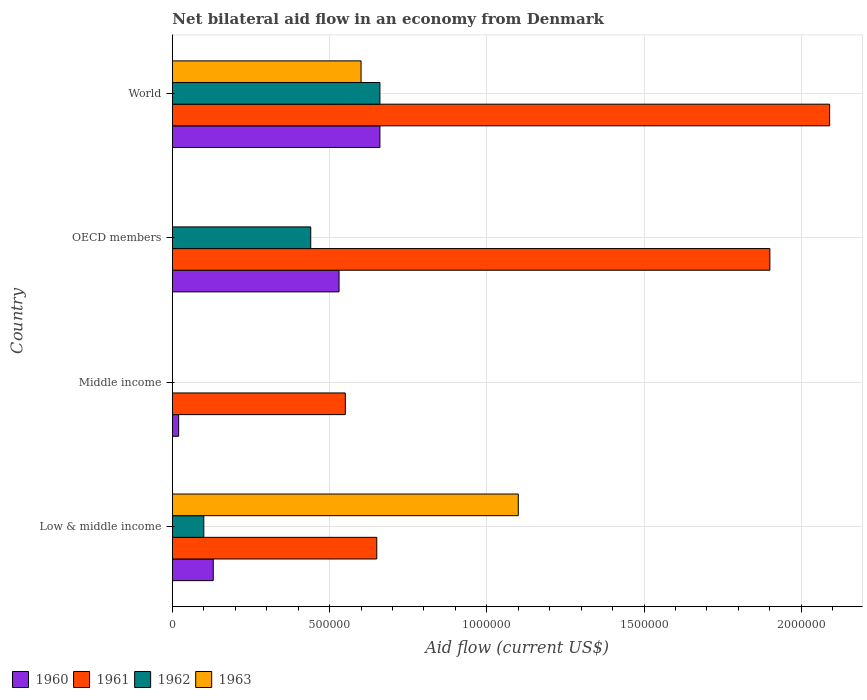How many different coloured bars are there?
Make the answer very short. 4. How many bars are there on the 4th tick from the top?
Your response must be concise. 4. How many bars are there on the 3rd tick from the bottom?
Provide a short and direct response. 3. In how many cases, is the number of bars for a given country not equal to the number of legend labels?
Provide a succinct answer. 2. Across all countries, what is the maximum net bilateral aid flow in 1961?
Your answer should be compact. 2.09e+06. Across all countries, what is the minimum net bilateral aid flow in 1960?
Make the answer very short. 2.00e+04. In which country was the net bilateral aid flow in 1962 maximum?
Keep it short and to the point. World. What is the total net bilateral aid flow in 1962 in the graph?
Your answer should be compact. 1.20e+06. What is the difference between the net bilateral aid flow in 1962 in Low & middle income and that in World?
Offer a very short reply. -5.60e+05. What is the average net bilateral aid flow in 1960 per country?
Provide a short and direct response. 3.35e+05. What is the difference between the net bilateral aid flow in 1963 and net bilateral aid flow in 1960 in Low & middle income?
Your response must be concise. 9.70e+05. What is the ratio of the net bilateral aid flow in 1960 in Middle income to that in World?
Provide a succinct answer. 0.03. Is the net bilateral aid flow in 1961 in Low & middle income less than that in OECD members?
Make the answer very short. Yes. What is the difference between the highest and the second highest net bilateral aid flow in 1962?
Keep it short and to the point. 2.20e+05. What is the difference between the highest and the lowest net bilateral aid flow in 1960?
Offer a terse response. 6.40e+05. In how many countries, is the net bilateral aid flow in 1960 greater than the average net bilateral aid flow in 1960 taken over all countries?
Your answer should be very brief. 2. Is it the case that in every country, the sum of the net bilateral aid flow in 1962 and net bilateral aid flow in 1961 is greater than the sum of net bilateral aid flow in 1963 and net bilateral aid flow in 1960?
Offer a terse response. No. How many bars are there?
Offer a very short reply. 13. Are all the bars in the graph horizontal?
Give a very brief answer. Yes. How many countries are there in the graph?
Your answer should be compact. 4. Does the graph contain any zero values?
Ensure brevity in your answer.  Yes. How many legend labels are there?
Offer a very short reply. 4. How are the legend labels stacked?
Your answer should be very brief. Horizontal. What is the title of the graph?
Offer a very short reply. Net bilateral aid flow in an economy from Denmark. What is the label or title of the X-axis?
Your answer should be compact. Aid flow (current US$). What is the label or title of the Y-axis?
Your response must be concise. Country. What is the Aid flow (current US$) in 1961 in Low & middle income?
Provide a succinct answer. 6.50e+05. What is the Aid flow (current US$) in 1962 in Low & middle income?
Offer a terse response. 1.00e+05. What is the Aid flow (current US$) of 1963 in Low & middle income?
Ensure brevity in your answer.  1.10e+06. What is the Aid flow (current US$) in 1960 in Middle income?
Offer a terse response. 2.00e+04. What is the Aid flow (current US$) in 1961 in Middle income?
Your response must be concise. 5.50e+05. What is the Aid flow (current US$) in 1962 in Middle income?
Ensure brevity in your answer.  0. What is the Aid flow (current US$) in 1963 in Middle income?
Keep it short and to the point. 0. What is the Aid flow (current US$) in 1960 in OECD members?
Ensure brevity in your answer.  5.30e+05. What is the Aid flow (current US$) in 1961 in OECD members?
Give a very brief answer. 1.90e+06. What is the Aid flow (current US$) in 1963 in OECD members?
Your answer should be compact. 0. What is the Aid flow (current US$) in 1960 in World?
Keep it short and to the point. 6.60e+05. What is the Aid flow (current US$) of 1961 in World?
Your answer should be very brief. 2.09e+06. What is the Aid flow (current US$) of 1962 in World?
Provide a succinct answer. 6.60e+05. Across all countries, what is the maximum Aid flow (current US$) of 1961?
Your response must be concise. 2.09e+06. Across all countries, what is the maximum Aid flow (current US$) of 1963?
Your answer should be very brief. 1.10e+06. Across all countries, what is the minimum Aid flow (current US$) in 1960?
Keep it short and to the point. 2.00e+04. Across all countries, what is the minimum Aid flow (current US$) in 1961?
Provide a short and direct response. 5.50e+05. Across all countries, what is the minimum Aid flow (current US$) of 1962?
Give a very brief answer. 0. Across all countries, what is the minimum Aid flow (current US$) in 1963?
Your answer should be compact. 0. What is the total Aid flow (current US$) of 1960 in the graph?
Make the answer very short. 1.34e+06. What is the total Aid flow (current US$) in 1961 in the graph?
Provide a succinct answer. 5.19e+06. What is the total Aid flow (current US$) of 1962 in the graph?
Keep it short and to the point. 1.20e+06. What is the total Aid flow (current US$) of 1963 in the graph?
Your answer should be very brief. 1.70e+06. What is the difference between the Aid flow (current US$) in 1961 in Low & middle income and that in Middle income?
Your answer should be compact. 1.00e+05. What is the difference between the Aid flow (current US$) of 1960 in Low & middle income and that in OECD members?
Offer a terse response. -4.00e+05. What is the difference between the Aid flow (current US$) of 1961 in Low & middle income and that in OECD members?
Ensure brevity in your answer.  -1.25e+06. What is the difference between the Aid flow (current US$) of 1962 in Low & middle income and that in OECD members?
Your answer should be very brief. -3.40e+05. What is the difference between the Aid flow (current US$) in 1960 in Low & middle income and that in World?
Keep it short and to the point. -5.30e+05. What is the difference between the Aid flow (current US$) of 1961 in Low & middle income and that in World?
Your answer should be compact. -1.44e+06. What is the difference between the Aid flow (current US$) in 1962 in Low & middle income and that in World?
Give a very brief answer. -5.60e+05. What is the difference between the Aid flow (current US$) of 1960 in Middle income and that in OECD members?
Your response must be concise. -5.10e+05. What is the difference between the Aid flow (current US$) of 1961 in Middle income and that in OECD members?
Keep it short and to the point. -1.35e+06. What is the difference between the Aid flow (current US$) in 1960 in Middle income and that in World?
Provide a short and direct response. -6.40e+05. What is the difference between the Aid flow (current US$) in 1961 in Middle income and that in World?
Ensure brevity in your answer.  -1.54e+06. What is the difference between the Aid flow (current US$) in 1961 in OECD members and that in World?
Provide a short and direct response. -1.90e+05. What is the difference between the Aid flow (current US$) of 1960 in Low & middle income and the Aid flow (current US$) of 1961 in Middle income?
Ensure brevity in your answer.  -4.20e+05. What is the difference between the Aid flow (current US$) of 1960 in Low & middle income and the Aid flow (current US$) of 1961 in OECD members?
Offer a terse response. -1.77e+06. What is the difference between the Aid flow (current US$) of 1960 in Low & middle income and the Aid flow (current US$) of 1962 in OECD members?
Your answer should be compact. -3.10e+05. What is the difference between the Aid flow (current US$) of 1960 in Low & middle income and the Aid flow (current US$) of 1961 in World?
Offer a very short reply. -1.96e+06. What is the difference between the Aid flow (current US$) in 1960 in Low & middle income and the Aid flow (current US$) in 1962 in World?
Offer a terse response. -5.30e+05. What is the difference between the Aid flow (current US$) of 1960 in Low & middle income and the Aid flow (current US$) of 1963 in World?
Your response must be concise. -4.70e+05. What is the difference between the Aid flow (current US$) in 1961 in Low & middle income and the Aid flow (current US$) in 1962 in World?
Your answer should be very brief. -10000. What is the difference between the Aid flow (current US$) in 1962 in Low & middle income and the Aid flow (current US$) in 1963 in World?
Keep it short and to the point. -5.00e+05. What is the difference between the Aid flow (current US$) in 1960 in Middle income and the Aid flow (current US$) in 1961 in OECD members?
Your answer should be compact. -1.88e+06. What is the difference between the Aid flow (current US$) in 1960 in Middle income and the Aid flow (current US$) in 1962 in OECD members?
Make the answer very short. -4.20e+05. What is the difference between the Aid flow (current US$) in 1960 in Middle income and the Aid flow (current US$) in 1961 in World?
Provide a short and direct response. -2.07e+06. What is the difference between the Aid flow (current US$) of 1960 in Middle income and the Aid flow (current US$) of 1962 in World?
Make the answer very short. -6.40e+05. What is the difference between the Aid flow (current US$) of 1960 in Middle income and the Aid flow (current US$) of 1963 in World?
Keep it short and to the point. -5.80e+05. What is the difference between the Aid flow (current US$) in 1961 in Middle income and the Aid flow (current US$) in 1963 in World?
Make the answer very short. -5.00e+04. What is the difference between the Aid flow (current US$) of 1960 in OECD members and the Aid flow (current US$) of 1961 in World?
Give a very brief answer. -1.56e+06. What is the difference between the Aid flow (current US$) in 1960 in OECD members and the Aid flow (current US$) in 1962 in World?
Offer a very short reply. -1.30e+05. What is the difference between the Aid flow (current US$) of 1960 in OECD members and the Aid flow (current US$) of 1963 in World?
Keep it short and to the point. -7.00e+04. What is the difference between the Aid flow (current US$) of 1961 in OECD members and the Aid flow (current US$) of 1962 in World?
Your answer should be very brief. 1.24e+06. What is the difference between the Aid flow (current US$) in 1961 in OECD members and the Aid flow (current US$) in 1963 in World?
Your answer should be very brief. 1.30e+06. What is the average Aid flow (current US$) of 1960 per country?
Make the answer very short. 3.35e+05. What is the average Aid flow (current US$) in 1961 per country?
Your answer should be compact. 1.30e+06. What is the average Aid flow (current US$) in 1963 per country?
Your answer should be compact. 4.25e+05. What is the difference between the Aid flow (current US$) of 1960 and Aid flow (current US$) of 1961 in Low & middle income?
Make the answer very short. -5.20e+05. What is the difference between the Aid flow (current US$) in 1960 and Aid flow (current US$) in 1962 in Low & middle income?
Provide a succinct answer. 3.00e+04. What is the difference between the Aid flow (current US$) in 1960 and Aid flow (current US$) in 1963 in Low & middle income?
Give a very brief answer. -9.70e+05. What is the difference between the Aid flow (current US$) in 1961 and Aid flow (current US$) in 1962 in Low & middle income?
Your response must be concise. 5.50e+05. What is the difference between the Aid flow (current US$) in 1961 and Aid flow (current US$) in 1963 in Low & middle income?
Provide a short and direct response. -4.50e+05. What is the difference between the Aid flow (current US$) of 1960 and Aid flow (current US$) of 1961 in Middle income?
Your answer should be very brief. -5.30e+05. What is the difference between the Aid flow (current US$) in 1960 and Aid flow (current US$) in 1961 in OECD members?
Your response must be concise. -1.37e+06. What is the difference between the Aid flow (current US$) of 1960 and Aid flow (current US$) of 1962 in OECD members?
Offer a very short reply. 9.00e+04. What is the difference between the Aid flow (current US$) of 1961 and Aid flow (current US$) of 1962 in OECD members?
Make the answer very short. 1.46e+06. What is the difference between the Aid flow (current US$) of 1960 and Aid flow (current US$) of 1961 in World?
Provide a short and direct response. -1.43e+06. What is the difference between the Aid flow (current US$) of 1960 and Aid flow (current US$) of 1963 in World?
Your answer should be very brief. 6.00e+04. What is the difference between the Aid flow (current US$) in 1961 and Aid flow (current US$) in 1962 in World?
Your answer should be very brief. 1.43e+06. What is the difference between the Aid flow (current US$) of 1961 and Aid flow (current US$) of 1963 in World?
Keep it short and to the point. 1.49e+06. What is the ratio of the Aid flow (current US$) in 1961 in Low & middle income to that in Middle income?
Your answer should be very brief. 1.18. What is the ratio of the Aid flow (current US$) of 1960 in Low & middle income to that in OECD members?
Ensure brevity in your answer.  0.25. What is the ratio of the Aid flow (current US$) in 1961 in Low & middle income to that in OECD members?
Your answer should be very brief. 0.34. What is the ratio of the Aid flow (current US$) in 1962 in Low & middle income to that in OECD members?
Offer a very short reply. 0.23. What is the ratio of the Aid flow (current US$) in 1960 in Low & middle income to that in World?
Offer a very short reply. 0.2. What is the ratio of the Aid flow (current US$) in 1961 in Low & middle income to that in World?
Offer a terse response. 0.31. What is the ratio of the Aid flow (current US$) of 1962 in Low & middle income to that in World?
Your answer should be compact. 0.15. What is the ratio of the Aid flow (current US$) of 1963 in Low & middle income to that in World?
Your response must be concise. 1.83. What is the ratio of the Aid flow (current US$) in 1960 in Middle income to that in OECD members?
Ensure brevity in your answer.  0.04. What is the ratio of the Aid flow (current US$) in 1961 in Middle income to that in OECD members?
Your response must be concise. 0.29. What is the ratio of the Aid flow (current US$) of 1960 in Middle income to that in World?
Provide a succinct answer. 0.03. What is the ratio of the Aid flow (current US$) of 1961 in Middle income to that in World?
Keep it short and to the point. 0.26. What is the ratio of the Aid flow (current US$) of 1960 in OECD members to that in World?
Your response must be concise. 0.8. What is the ratio of the Aid flow (current US$) in 1961 in OECD members to that in World?
Provide a short and direct response. 0.91. What is the difference between the highest and the lowest Aid flow (current US$) of 1960?
Your answer should be very brief. 6.40e+05. What is the difference between the highest and the lowest Aid flow (current US$) of 1961?
Keep it short and to the point. 1.54e+06. What is the difference between the highest and the lowest Aid flow (current US$) of 1962?
Your response must be concise. 6.60e+05. What is the difference between the highest and the lowest Aid flow (current US$) of 1963?
Provide a short and direct response. 1.10e+06. 